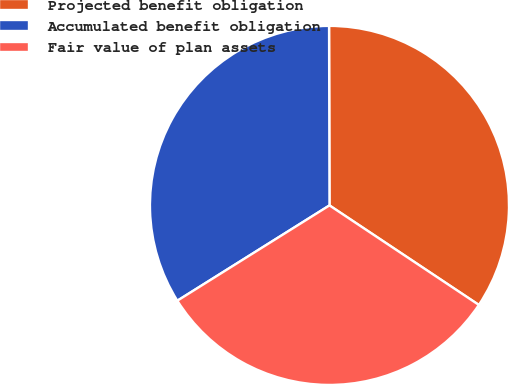Convert chart. <chart><loc_0><loc_0><loc_500><loc_500><pie_chart><fcel>Projected benefit obligation<fcel>Accumulated benefit obligation<fcel>Fair value of plan assets<nl><fcel>34.39%<fcel>33.87%<fcel>31.74%<nl></chart> 